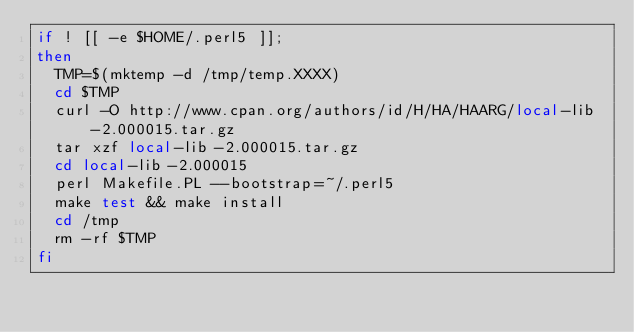Convert code to text. <code><loc_0><loc_0><loc_500><loc_500><_Bash_>if ! [[ -e $HOME/.perl5 ]];
then
  TMP=$(mktemp -d /tmp/temp.XXXX)
  cd $TMP
  curl -O http://www.cpan.org/authors/id/H/HA/HAARG/local-lib-2.000015.tar.gz
  tar xzf local-lib-2.000015.tar.gz
  cd local-lib-2.000015
  perl Makefile.PL --bootstrap=~/.perl5
  make test && make install
  cd /tmp
  rm -rf $TMP
fi
</code> 